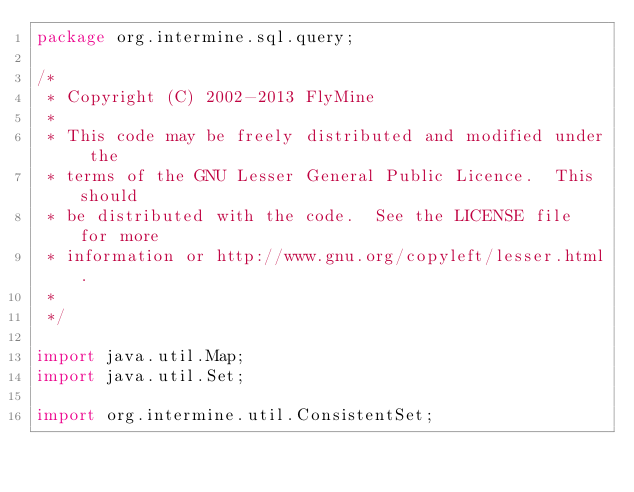Convert code to text. <code><loc_0><loc_0><loc_500><loc_500><_Java_>package org.intermine.sql.query;

/*
 * Copyright (C) 2002-2013 FlyMine
 *
 * This code may be freely distributed and modified under the
 * terms of the GNU Lesser General Public Licence.  This should
 * be distributed with the code.  See the LICENSE file for more
 * information or http://www.gnu.org/copyleft/lesser.html.
 *
 */

import java.util.Map;
import java.util.Set;

import org.intermine.util.ConsistentSet;
</code> 